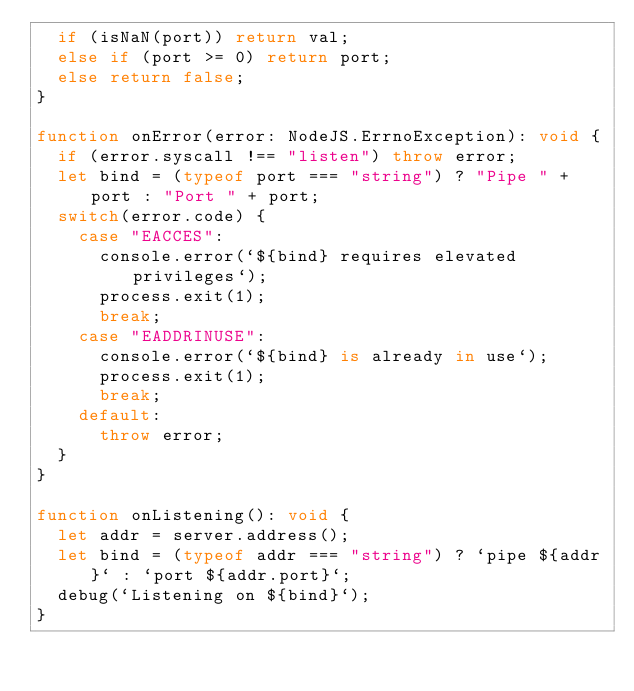Convert code to text. <code><loc_0><loc_0><loc_500><loc_500><_TypeScript_>  if (isNaN(port)) return val;
  else if (port >= 0) return port;
  else return false;
}

function onError(error: NodeJS.ErrnoException): void {
  if (error.syscall !== "listen") throw error;
  let bind = (typeof port === "string") ? "Pipe " + port : "Port " + port;
  switch(error.code) {
    case "EACCES":
      console.error(`${bind} requires elevated privileges`);
      process.exit(1);
      break;
    case "EADDRINUSE":
      console.error(`${bind} is already in use`);
      process.exit(1);
      break;
    default:
      throw error;
  }
}

function onListening(): void {
  let addr = server.address();
  let bind = (typeof addr === "string") ? `pipe ${addr}` : `port ${addr.port}`;
  debug(`Listening on ${bind}`);
}
</code> 